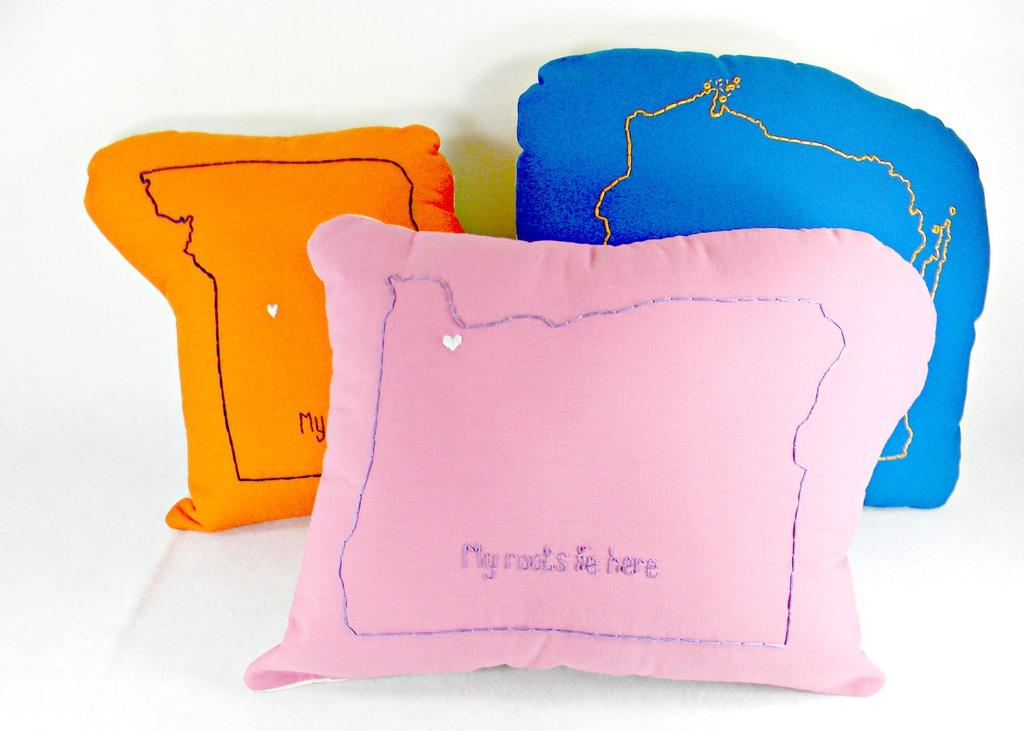What type of objects can be seen in the image? There are cushions in the image. What is unique about the cushions? The cushions have embroidery work. What color is the surface of the cushions? The surface of the cushions is white. What rhythm does the cushion play in the image? There is no rhythm or sound associated with the cushions in the image; they are simply objects with embroidery work and a white surface. 